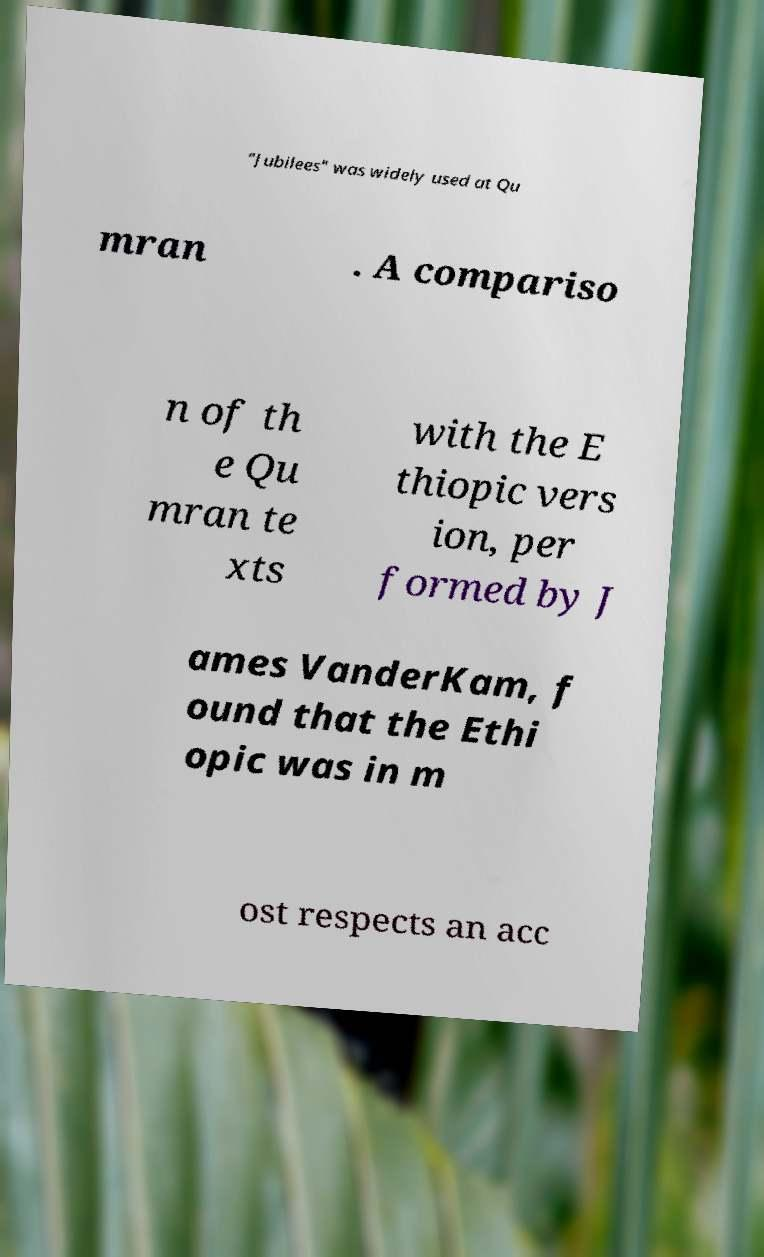Could you extract and type out the text from this image? "Jubilees" was widely used at Qu mran . A compariso n of th e Qu mran te xts with the E thiopic vers ion, per formed by J ames VanderKam, f ound that the Ethi opic was in m ost respects an acc 